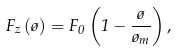Convert formula to latex. <formula><loc_0><loc_0><loc_500><loc_500>F _ { z } \left ( \tau \right ) = F _ { 0 } \left ( 1 - \frac { \tau } { \tau _ { m } } \right ) ,</formula> 